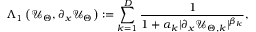Convert formula to latex. <formula><loc_0><loc_0><loc_500><loc_500>\Lambda _ { 1 } \left ( \mathcal { U } _ { \Theta } , \partial _ { x } \mathcal { U } _ { \Theta } \right ) \colon = \sum _ { k = 1 } ^ { D } \frac { 1 } { 1 + \alpha _ { k } \mathopen | \partial _ { x } \mathcal { U } _ { \Theta , k } \mathclose | ^ { \beta _ { k } } } ,</formula> 